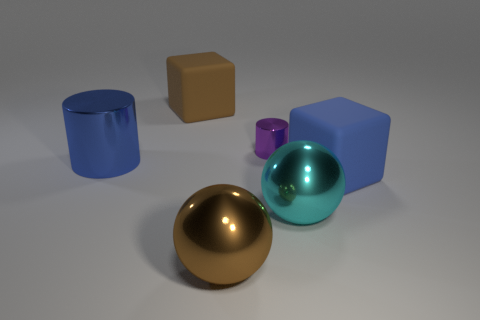Is the color of the cylinder that is behind the blue cylinder the same as the big metal cylinder?
Your response must be concise. No. Are there any blue rubber blocks to the left of the thing in front of the cyan thing?
Your answer should be compact. No. What is the material of the object that is both left of the purple cylinder and behind the big cylinder?
Make the answer very short. Rubber. The purple thing that is the same material as the cyan object is what shape?
Your answer should be compact. Cylinder. Are there any other things that are the same shape as the large brown matte thing?
Ensure brevity in your answer.  Yes. Is the big sphere left of the cyan shiny thing made of the same material as the cyan sphere?
Your response must be concise. Yes. There is a brown thing behind the small object; what is its material?
Your response must be concise. Rubber. How big is the rubber object that is on the left side of the big brown thing that is in front of the large cyan thing?
Make the answer very short. Large. What number of blue matte blocks have the same size as the brown metal sphere?
Your answer should be very brief. 1. Do the matte object left of the big blue matte cube and the matte block in front of the blue cylinder have the same color?
Offer a terse response. No. 